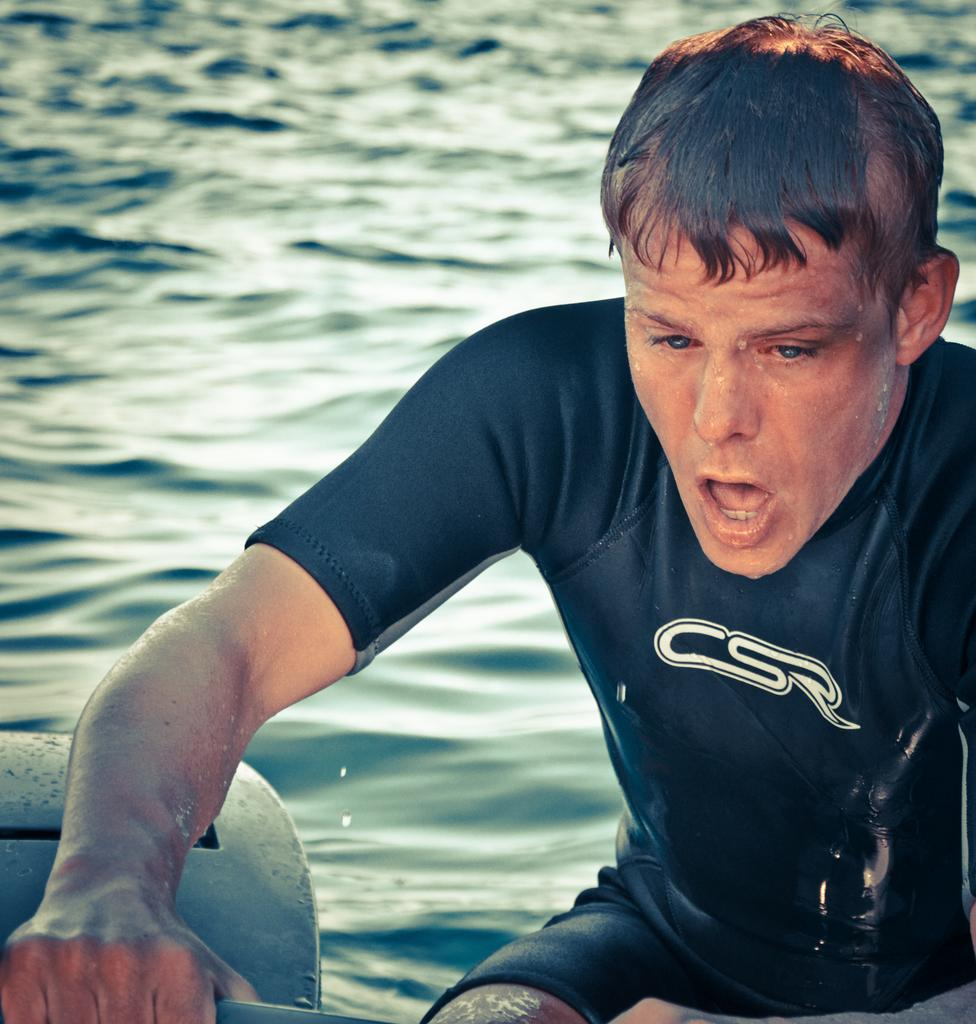What is present in the image? There is a person in the image. What is the person holding in their hand? The person is holding something in their hand. What can be seen in the background of the image? There is water visible in the background of the image. Can you describe the object near the person? There is an object near the person. What is the queen's thought process while holding the pot in the image? There is no queen or pot present in the image, so it is not possible to determine the queen's thought process. 